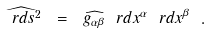<formula> <loc_0><loc_0><loc_500><loc_500>\widehat { \ r d s ^ { 2 } } \ = \ \widehat { g _ { \alpha \beta } } \ r d x ^ { \alpha } \ r d x ^ { \beta } \ .</formula> 